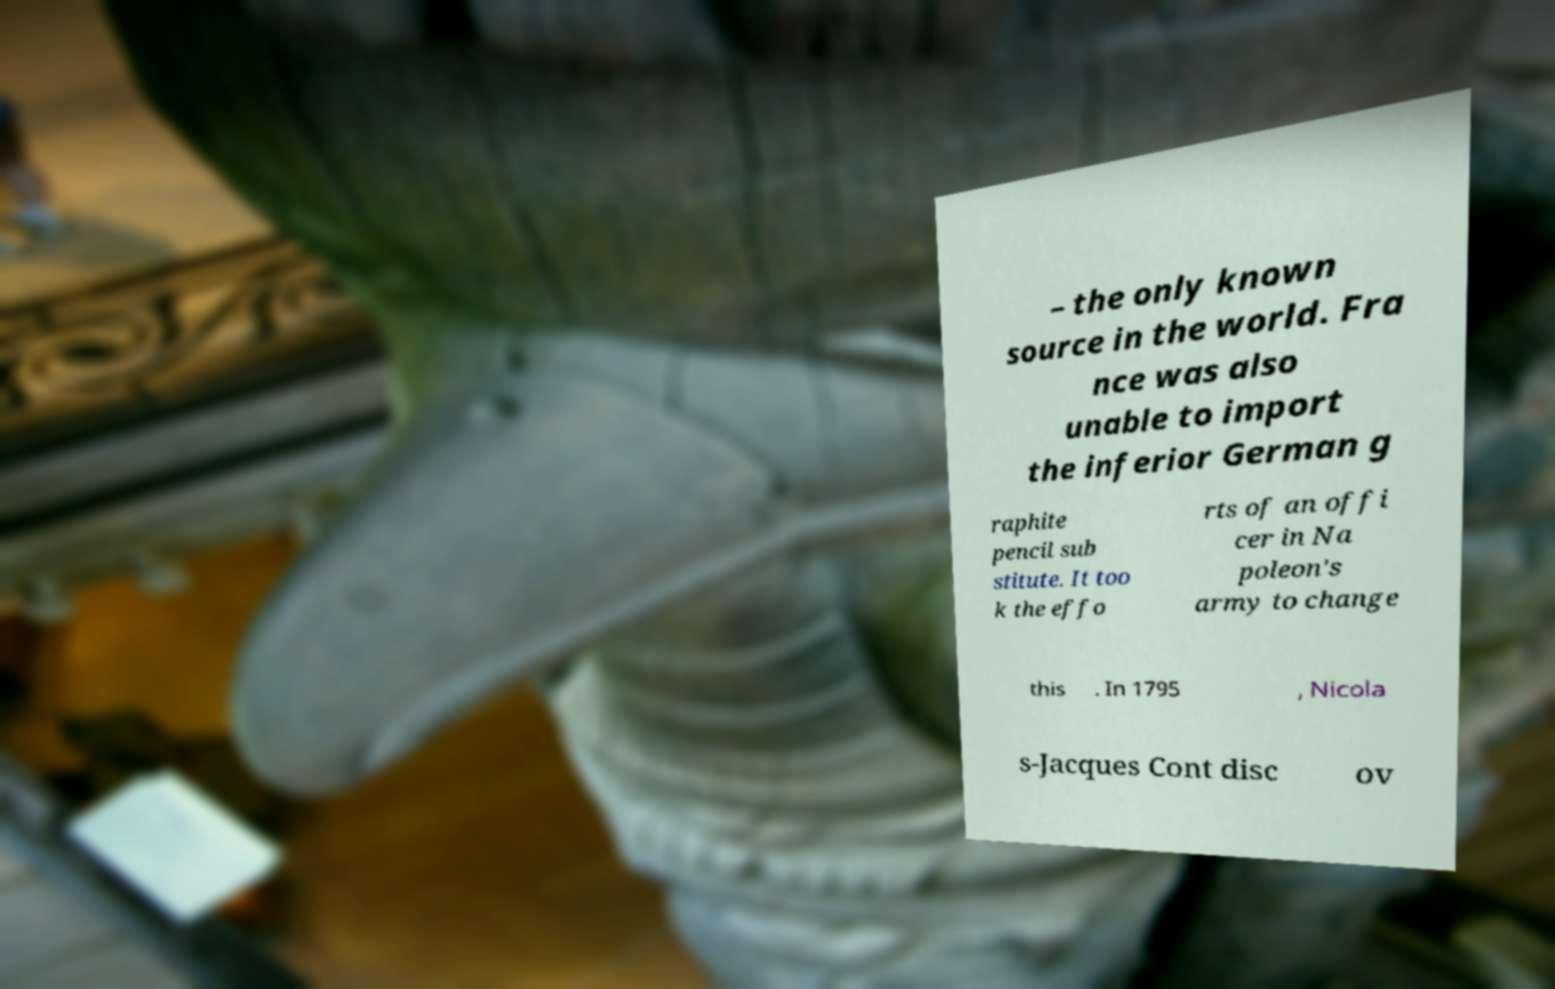Can you read and provide the text displayed in the image?This photo seems to have some interesting text. Can you extract and type it out for me? – the only known source in the world. Fra nce was also unable to import the inferior German g raphite pencil sub stitute. It too k the effo rts of an offi cer in Na poleon's army to change this . In 1795 , Nicola s-Jacques Cont disc ov 